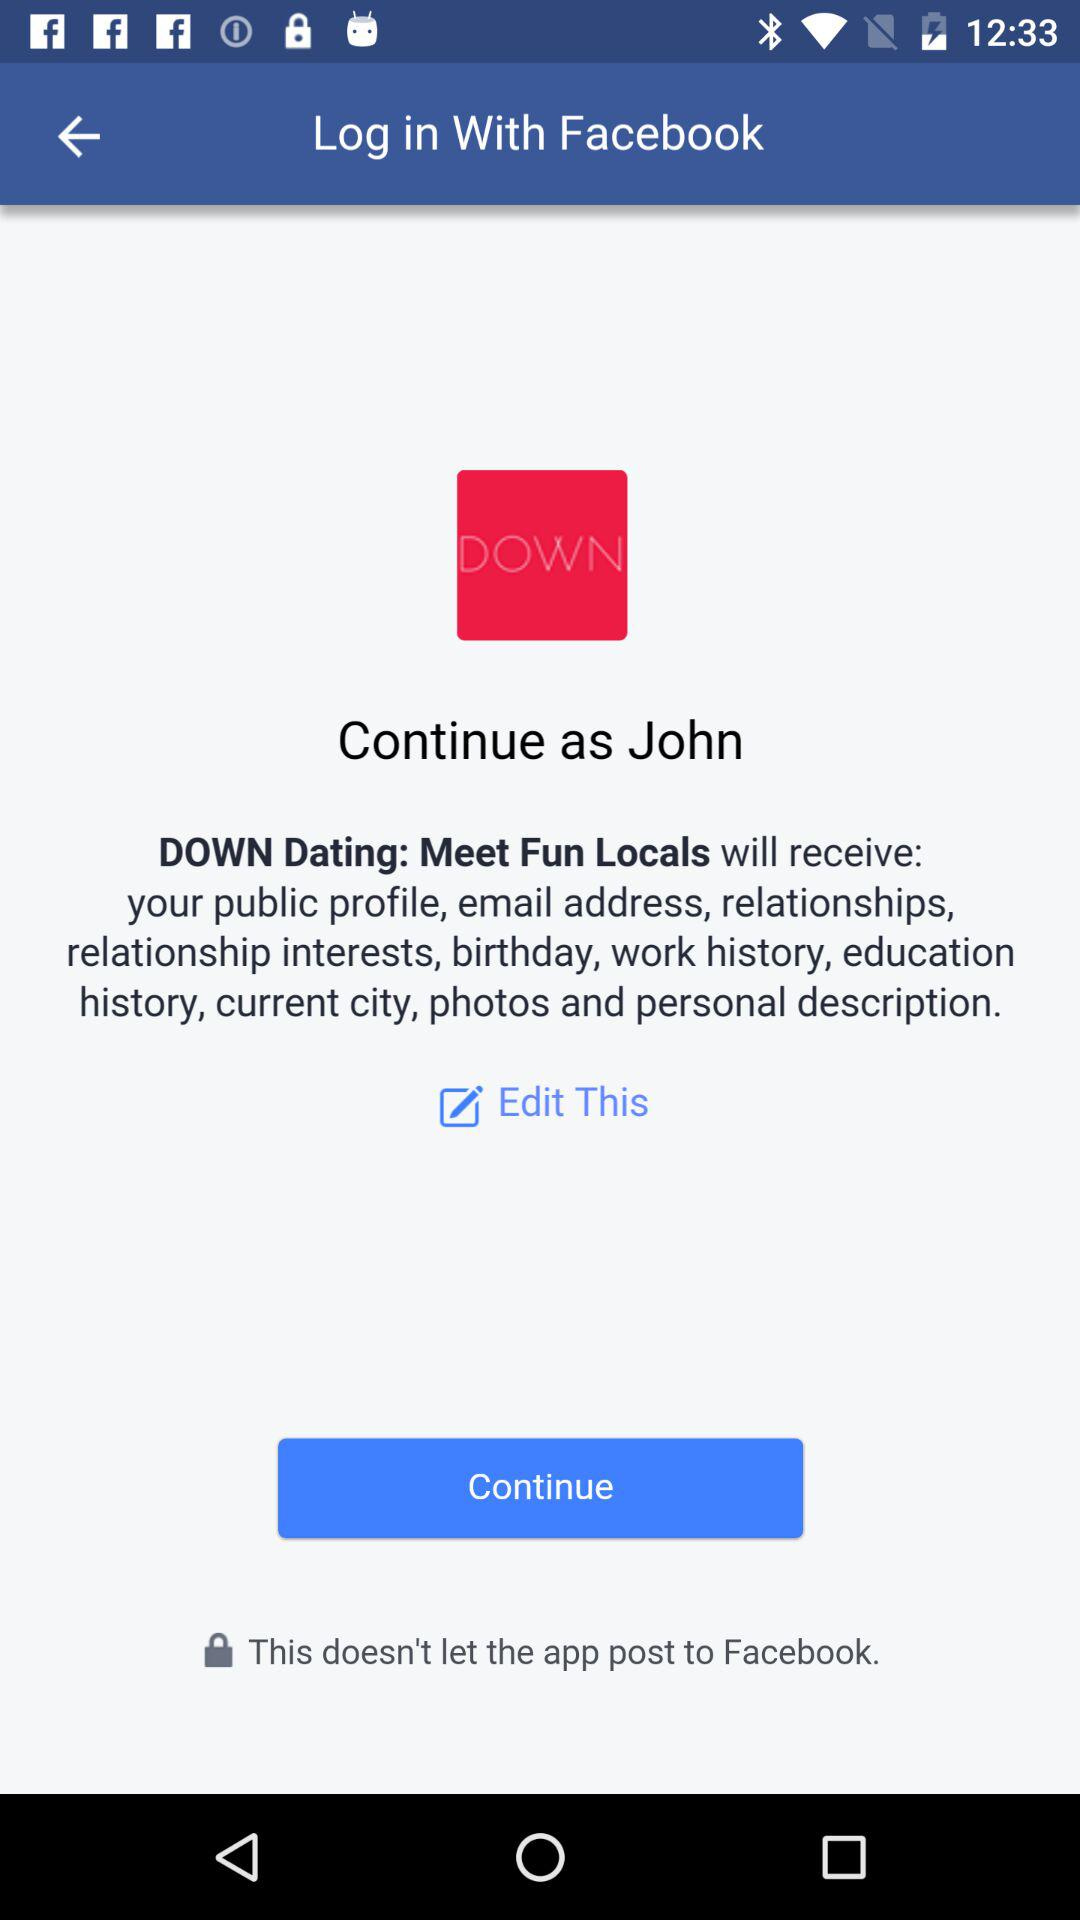What applications can be used to log in to the profile? The application that can be used to log in to the profile is "Facebook". 